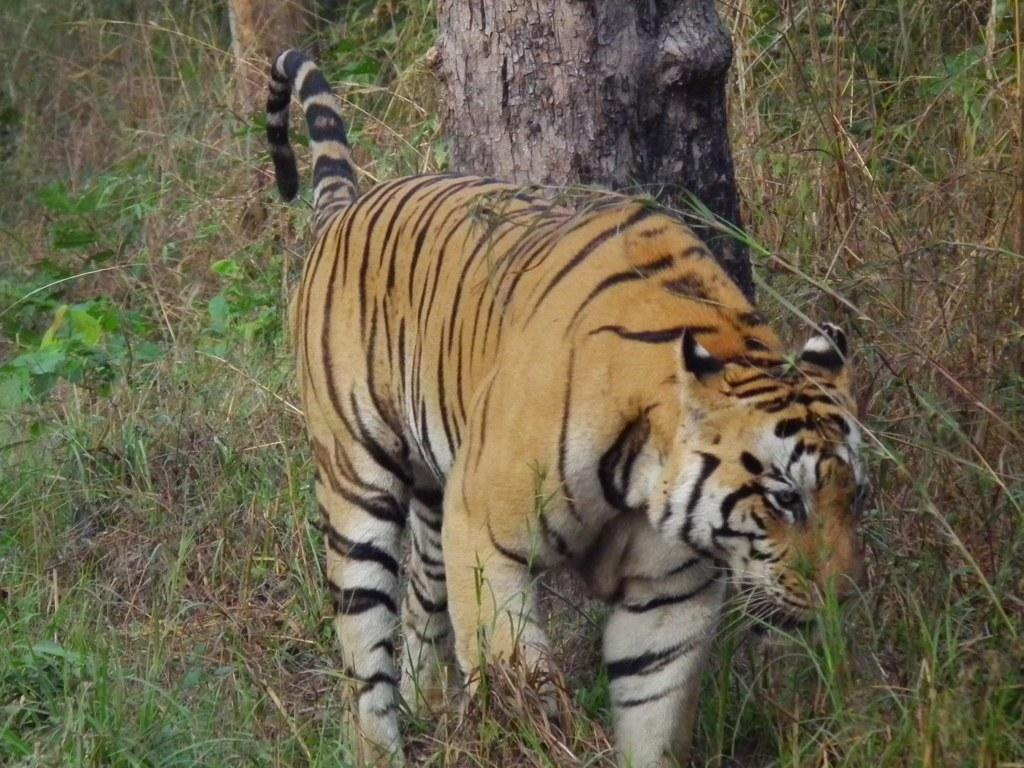What animal is the main subject of the picture? There is a lion in the picture. What type of terrain is the lion standing on? The lion is on the grass. What other natural elements can be seen in the picture? There are tree trunks in the picture. Can you see a river flowing near the lion in the picture? No, there is no river visible in the picture. 